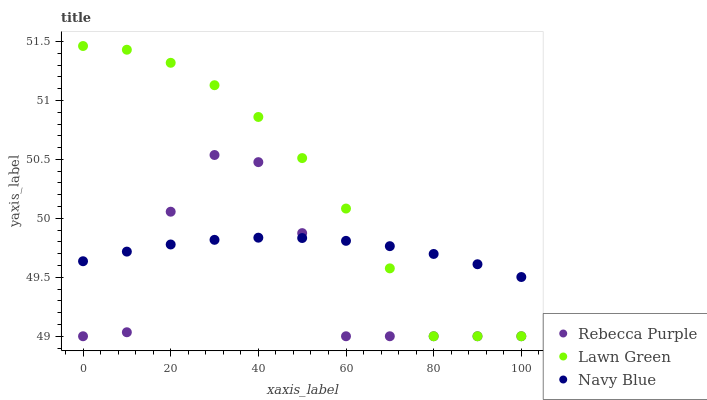Does Rebecca Purple have the minimum area under the curve?
Answer yes or no. Yes. Does Lawn Green have the maximum area under the curve?
Answer yes or no. Yes. Does Navy Blue have the minimum area under the curve?
Answer yes or no. No. Does Navy Blue have the maximum area under the curve?
Answer yes or no. No. Is Navy Blue the smoothest?
Answer yes or no. Yes. Is Rebecca Purple the roughest?
Answer yes or no. Yes. Is Rebecca Purple the smoothest?
Answer yes or no. No. Is Navy Blue the roughest?
Answer yes or no. No. Does Lawn Green have the lowest value?
Answer yes or no. Yes. Does Navy Blue have the lowest value?
Answer yes or no. No. Does Lawn Green have the highest value?
Answer yes or no. Yes. Does Rebecca Purple have the highest value?
Answer yes or no. No. Does Rebecca Purple intersect Navy Blue?
Answer yes or no. Yes. Is Rebecca Purple less than Navy Blue?
Answer yes or no. No. Is Rebecca Purple greater than Navy Blue?
Answer yes or no. No. 